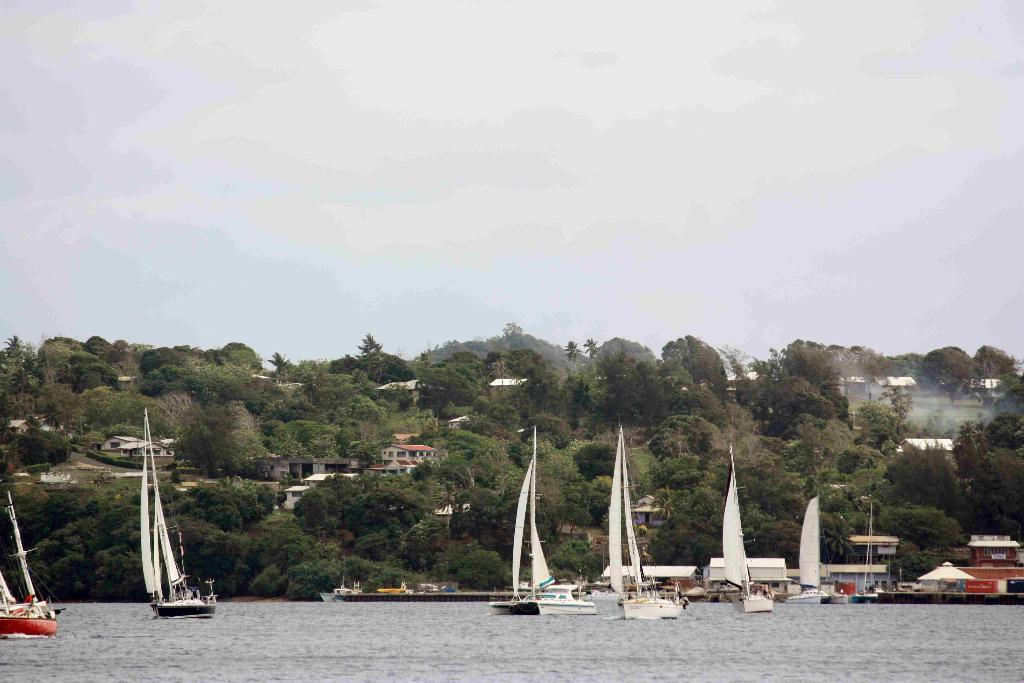What is the setting of the image? The image is an outside view. What can be seen on the water at the bottom of the image? There are many ships on the water at the bottom of the image. What types of structures and vegetation are in the middle of the image? There are many trees and buildings in the middle of the image. What is visible at the top of the image? The sky is visible at the top of the image. Can you see a kite flying in the sky in the image? There is no kite visible in the sky in the image. What type of comb is being used to style the trees in the image? There is no comb present in the image; the trees are natural and not styled. 